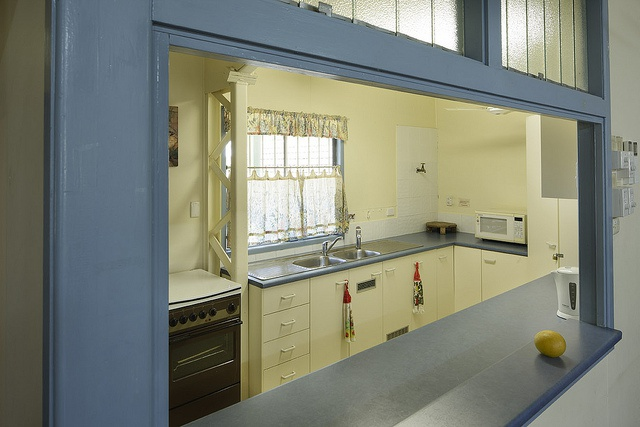Describe the objects in this image and their specific colors. I can see oven in black, tan, darkgreen, and beige tones, microwave in black, tan, and gray tones, sink in black, gray, darkgray, and lightgray tones, and sink in black, gray, darkgray, and darkgreen tones in this image. 